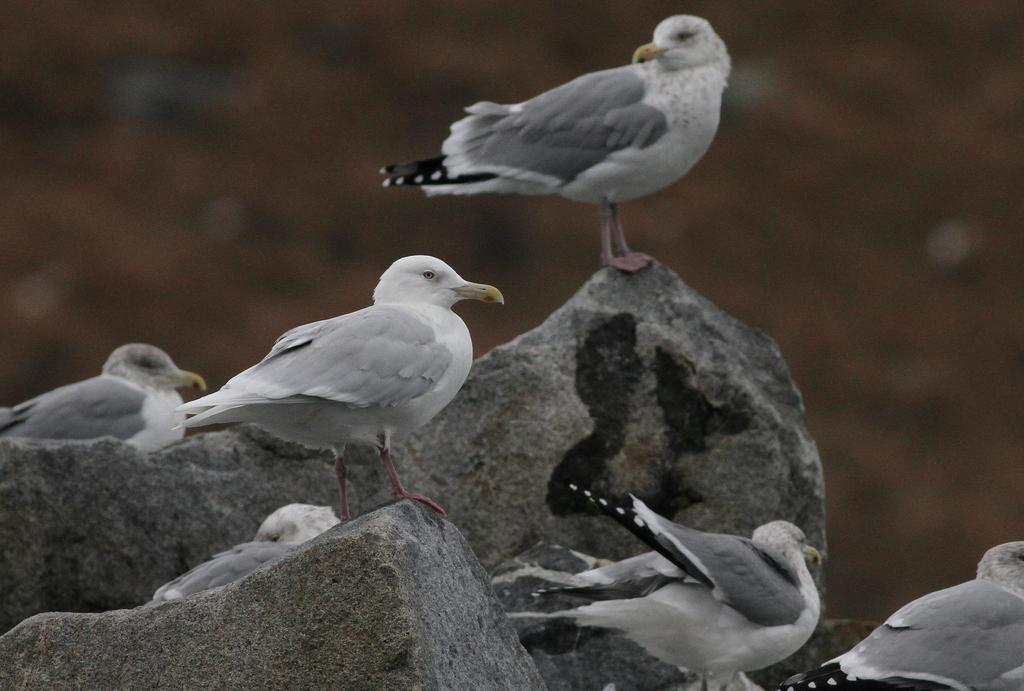What type of animals can be seen in the image? There are birds in the image. What colors are the birds in the image? The birds are in white and gray colors. What is at the bottom of the image? There are rocks at the bottom of the image. How would you describe the background of the image? The background of the image is blurred. What type of jar is visible in the image? There is no jar present in the image. How many weeks have passed since the birds were last seen in the image? The image does not provide information about the passage of time, so it is impossible to determine how many weeks have passed since the birds were last seen. 